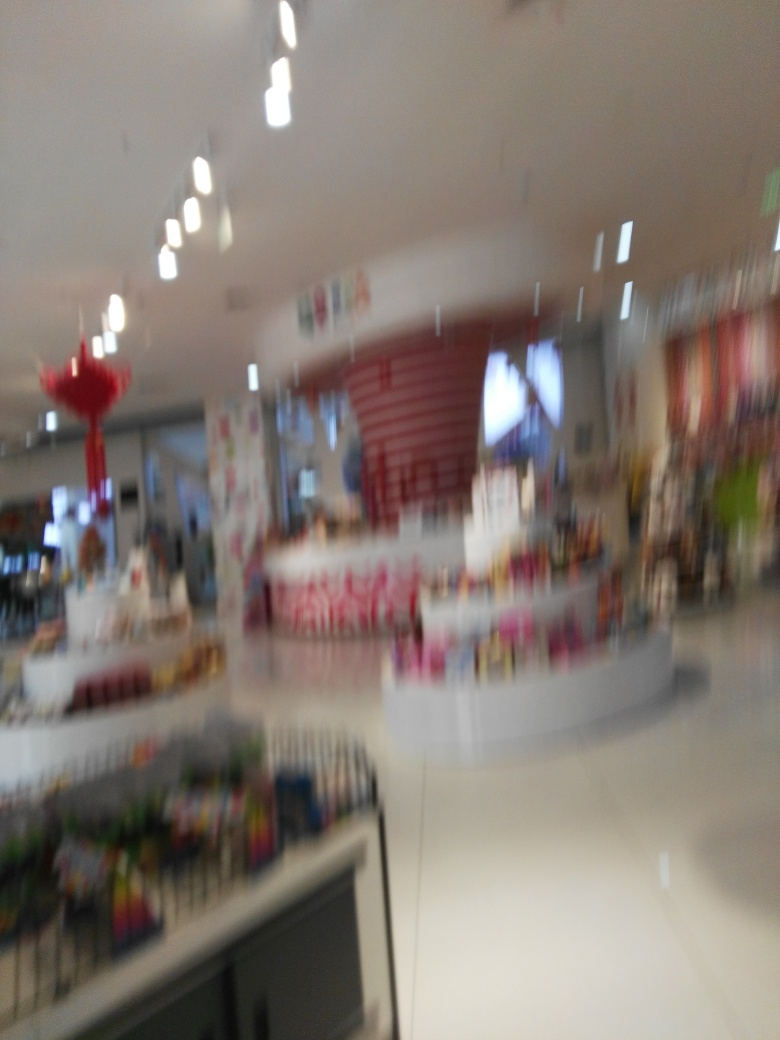Describe the colors which are visible in the image, despite the blurriness. The photo shows a blend of various colors. There are hints of red, possibly from a structure or piece of furniture within the space, along with neutral tones such as white and gray that could be the floor or walls. The lighting gives off a warm glow, causing lighter areas to stand out against the overall blurry backdrop. 